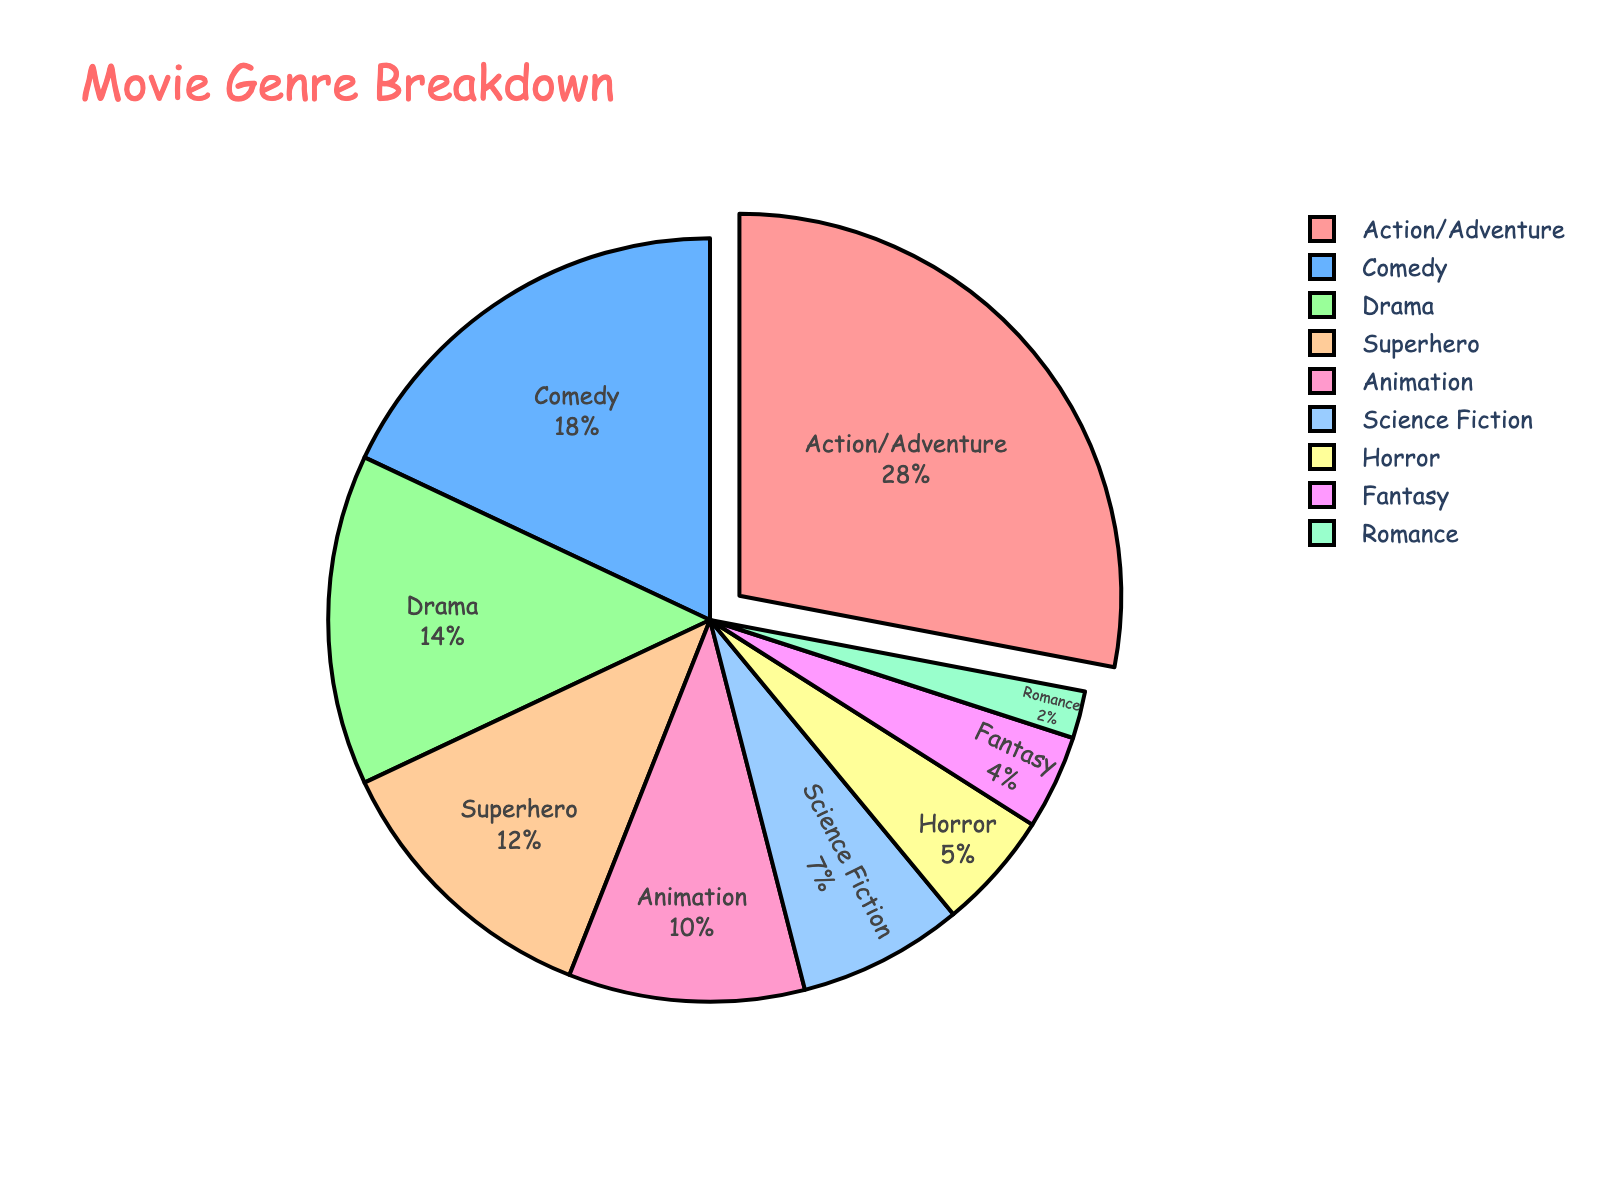What genre has the highest percentage in the pie chart? We look at the pie chart and see that the largest slice corresponds to Action/Adventure.
Answer: Action/Adventure How much more percentage does Action/Adventure have compared to Comedy? Action/Adventure has 28%, and Comedy has 18%. The difference is 28% - 18%.
Answer: 10% Which genres have a combined percentage equal to that of Action/Adventure? Summing different genre percentages: Comedy (18%) and Drama (14%) do not work since the sum is more. Considering Superhero (12%) and Animation (10%) which sum to 22%, and Science Fiction (7%) and Horror (5%) sum to 12%. The closest would be Superhero, Animation, and Science Fiction: 12% + 10% + 7% = 29%. This is slightly more than Action/Adventure, thus no exact match exists.
Answer: None exactly equal Which genre occupies the smallest section of the pie chart? Observing the slices, the smallest one corresponds to Romance.
Answer: Romance What is the total percentage of genres other than Action/Adventure and Comedy? First, determine the percentages of Action/Adventure (28%) and Comedy (18%). Summing their values (28% + 18% = 46%). Subtracting this from 100%, we get 100% - 46% = 54%.
Answer: 54% Do Animation and Fantasy together equal or surpass the percentage of Drama? Animation is 10% and Fantasy is 4%. The total is 10% + 4% = 14%, which is equal to the percentage of Drama.
Answer: Equal What color represents the Science Fiction genre in the pie chart? Looking at the colors indicated, Science Fiction is represented by light green.
Answer: light green Which genre has a percentage that is closest to but less than 10%? Checking the percentages, we see that Science Fiction is 7%, which is the closest yet less than 10%.
Answer: Science Fiction If you combined the Drama, Superhero, and Animation genres, would their total surpass Action/Adventure? Drama (14%) + Superhero (12%) + Animation (10%) sums up to 36%, which is greater than Action/Adventure's 28%.
Answer: Yes Compare the sum of percentages of Horror and Fantasy to Animation. Horror (5%) + Fantasy (4%) gives 9%, which is less than Animation's 10%.
Answer: Less than 